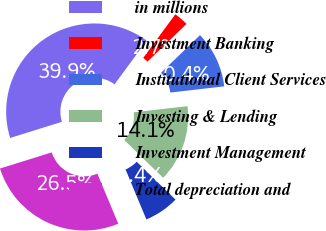Convert chart to OTSL. <chart><loc_0><loc_0><loc_500><loc_500><pie_chart><fcel>in millions<fcel>Investment Banking<fcel>Institutional Client Services<fcel>Investing & Lending<fcel>Investment Management<fcel>Total depreciation and<nl><fcel>39.91%<fcel>2.67%<fcel>10.4%<fcel>14.13%<fcel>6.4%<fcel>26.49%<nl></chart> 